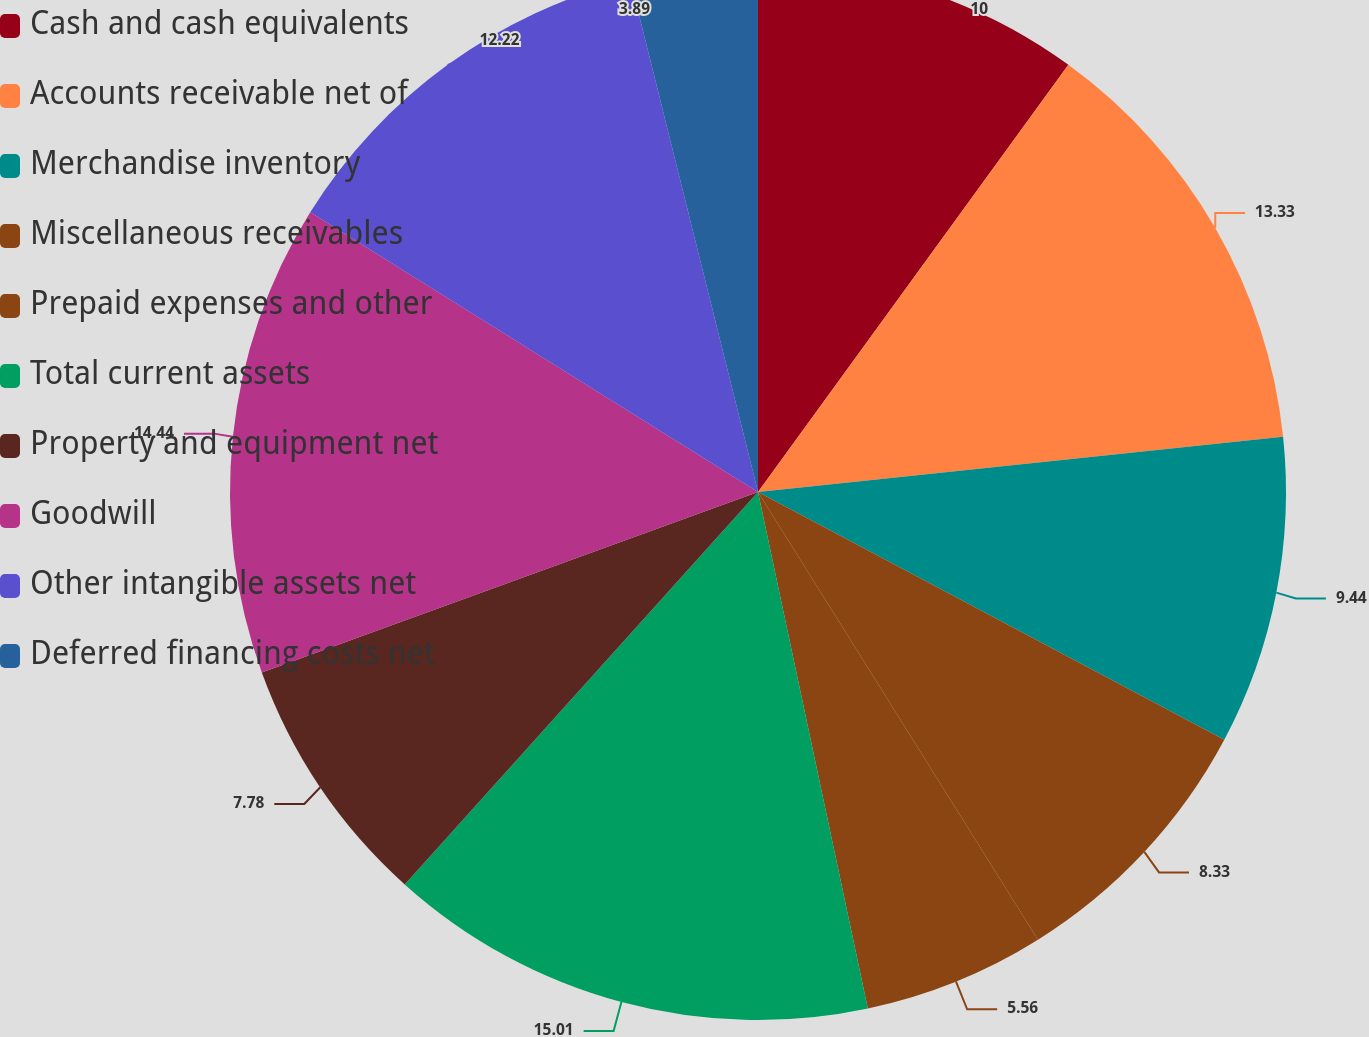Convert chart. <chart><loc_0><loc_0><loc_500><loc_500><pie_chart><fcel>Cash and cash equivalents<fcel>Accounts receivable net of<fcel>Merchandise inventory<fcel>Miscellaneous receivables<fcel>Prepaid expenses and other<fcel>Total current assets<fcel>Property and equipment net<fcel>Goodwill<fcel>Other intangible assets net<fcel>Deferred financing costs net<nl><fcel>10.0%<fcel>13.33%<fcel>9.44%<fcel>8.33%<fcel>5.56%<fcel>15.0%<fcel>7.78%<fcel>14.44%<fcel>12.22%<fcel>3.89%<nl></chart> 